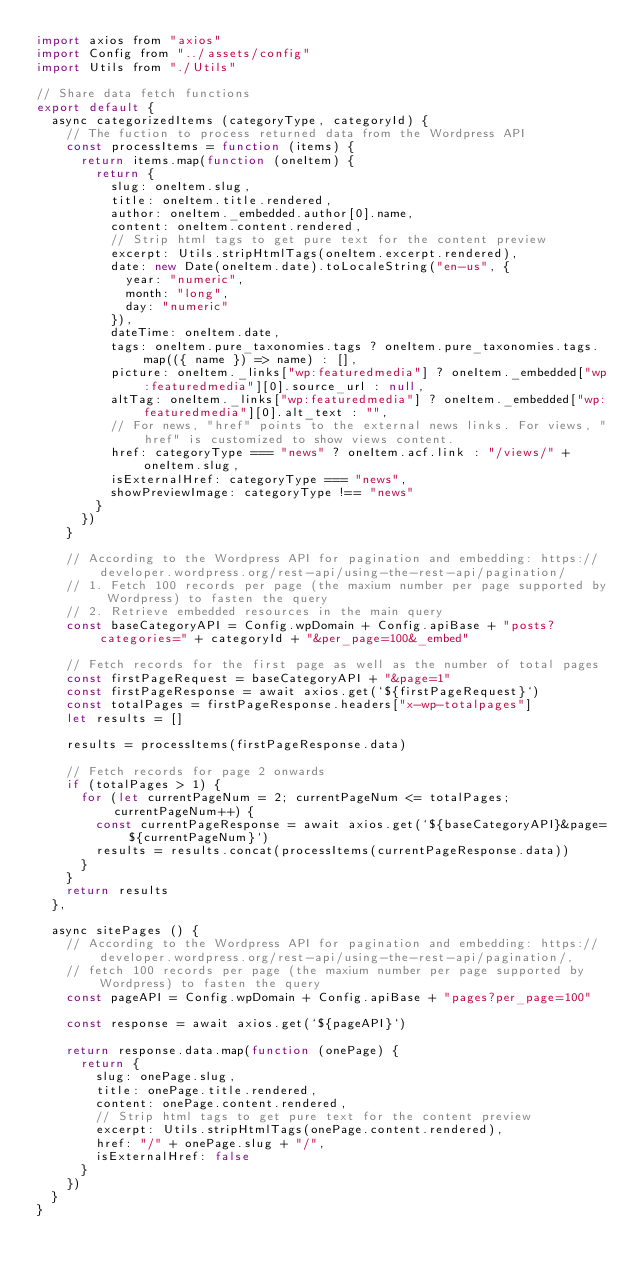<code> <loc_0><loc_0><loc_500><loc_500><_JavaScript_>import axios from "axios"
import Config from "../assets/config"
import Utils from "./Utils"

// Share data fetch functions
export default {
	async categorizedItems (categoryType, categoryId) {
		// The fuction to process returned data from the Wordpress API
		const processItems = function (items) {
			return items.map(function (oneItem) {
				return {
					slug: oneItem.slug,
					title: oneItem.title.rendered,
					author: oneItem._embedded.author[0].name,
					content: oneItem.content.rendered,
					// Strip html tags to get pure text for the content preview
					excerpt: Utils.stripHtmlTags(oneItem.excerpt.rendered),
					date: new Date(oneItem.date).toLocaleString("en-us", {
						year: "numeric",
						month: "long",
						day: "numeric"
					}),
					dateTime: oneItem.date,
					tags: oneItem.pure_taxonomies.tags ? oneItem.pure_taxonomies.tags.map(({ name }) => name) : [],
					picture: oneItem._links["wp:featuredmedia"] ? oneItem._embedded["wp:featuredmedia"][0].source_url : null,
					altTag: oneItem._links["wp:featuredmedia"] ? oneItem._embedded["wp:featuredmedia"][0].alt_text : "",
					// For news, "href" points to the external news links. For views, "href" is customized to show views content.
					href: categoryType === "news" ? oneItem.acf.link : "/views/" + oneItem.slug,
					isExternalHref: categoryType === "news",
					showPreviewImage: categoryType !== "news"
				}
			})
		}

		// According to the Wordpress API for pagination and embedding: https://developer.wordpress.org/rest-api/using-the-rest-api/pagination/
		// 1. Fetch 100 records per page (the maxium number per page supported by Wordpress) to fasten the query
		// 2. Retrieve embedded resources in the main query
		const baseCategoryAPI = Config.wpDomain + Config.apiBase + "posts?categories=" + categoryId + "&per_page=100&_embed"

		// Fetch records for the first page as well as the number of total pages
		const firstPageRequest = baseCategoryAPI + "&page=1"
		const firstPageResponse = await axios.get(`${firstPageRequest}`)
		const totalPages = firstPageResponse.headers["x-wp-totalpages"]
		let results = []

		results = processItems(firstPageResponse.data)

		// Fetch records for page 2 onwards
		if (totalPages > 1) {
			for (let currentPageNum = 2; currentPageNum <= totalPages; currentPageNum++) {
				const currentPageResponse = await axios.get(`${baseCategoryAPI}&page=${currentPageNum}`)
				results = results.concat(processItems(currentPageResponse.data))
			}
		}
		return results
	},

	async sitePages () {
		// According to the Wordpress API for pagination and embedding: https://developer.wordpress.org/rest-api/using-the-rest-api/pagination/,
		// fetch 100 records per page (the maxium number per page supported by Wordpress) to fasten the query
		const pageAPI = Config.wpDomain + Config.apiBase + "pages?per_page=100"

		const response = await axios.get(`${pageAPI}`)

		return response.data.map(function (onePage) {
			return {
				slug: onePage.slug,
				title: onePage.title.rendered,
				content: onePage.content.rendered,
				// Strip html tags to get pure text for the content preview
				excerpt: Utils.stripHtmlTags(onePage.content.rendered),
				href: "/" + onePage.slug + "/",
				isExternalHref: false
			}
		})
	}
}
</code> 